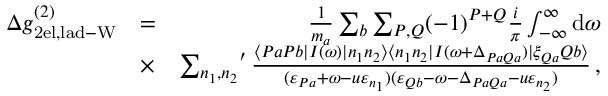Convert formula to latex. <formula><loc_0><loc_0><loc_500><loc_500>\begin{array} { r l r } { \Delta g _ { 2 e l , l a d - W } ^ { ( 2 ) } } & { = } & { \frac { 1 } { m _ { a } } \sum _ { b } \sum _ { P , Q } ( - 1 ) ^ { P + Q } \frac { i } { \pi } \int _ { - \infty } ^ { \infty } d \omega } \\ & { \times } & { { \sum _ { n _ { 1 } , n _ { 2 } } } ^ { \prime } \, \frac { \langle P a P b | I ( \omega ) | n _ { 1 } n _ { 2 } \rangle \langle n _ { 1 } n _ { 2 } | I ( \omega + \Delta _ { P a Q a } ) | \xi _ { Q a } Q b \rangle } { ( \varepsilon _ { P a } + \omega - u \varepsilon _ { n _ { 1 } } ) ( \varepsilon _ { Q b } - \omega - \Delta _ { P a Q a } - u \varepsilon _ { n _ { 2 } } ) } \, , } \end{array}</formula> 